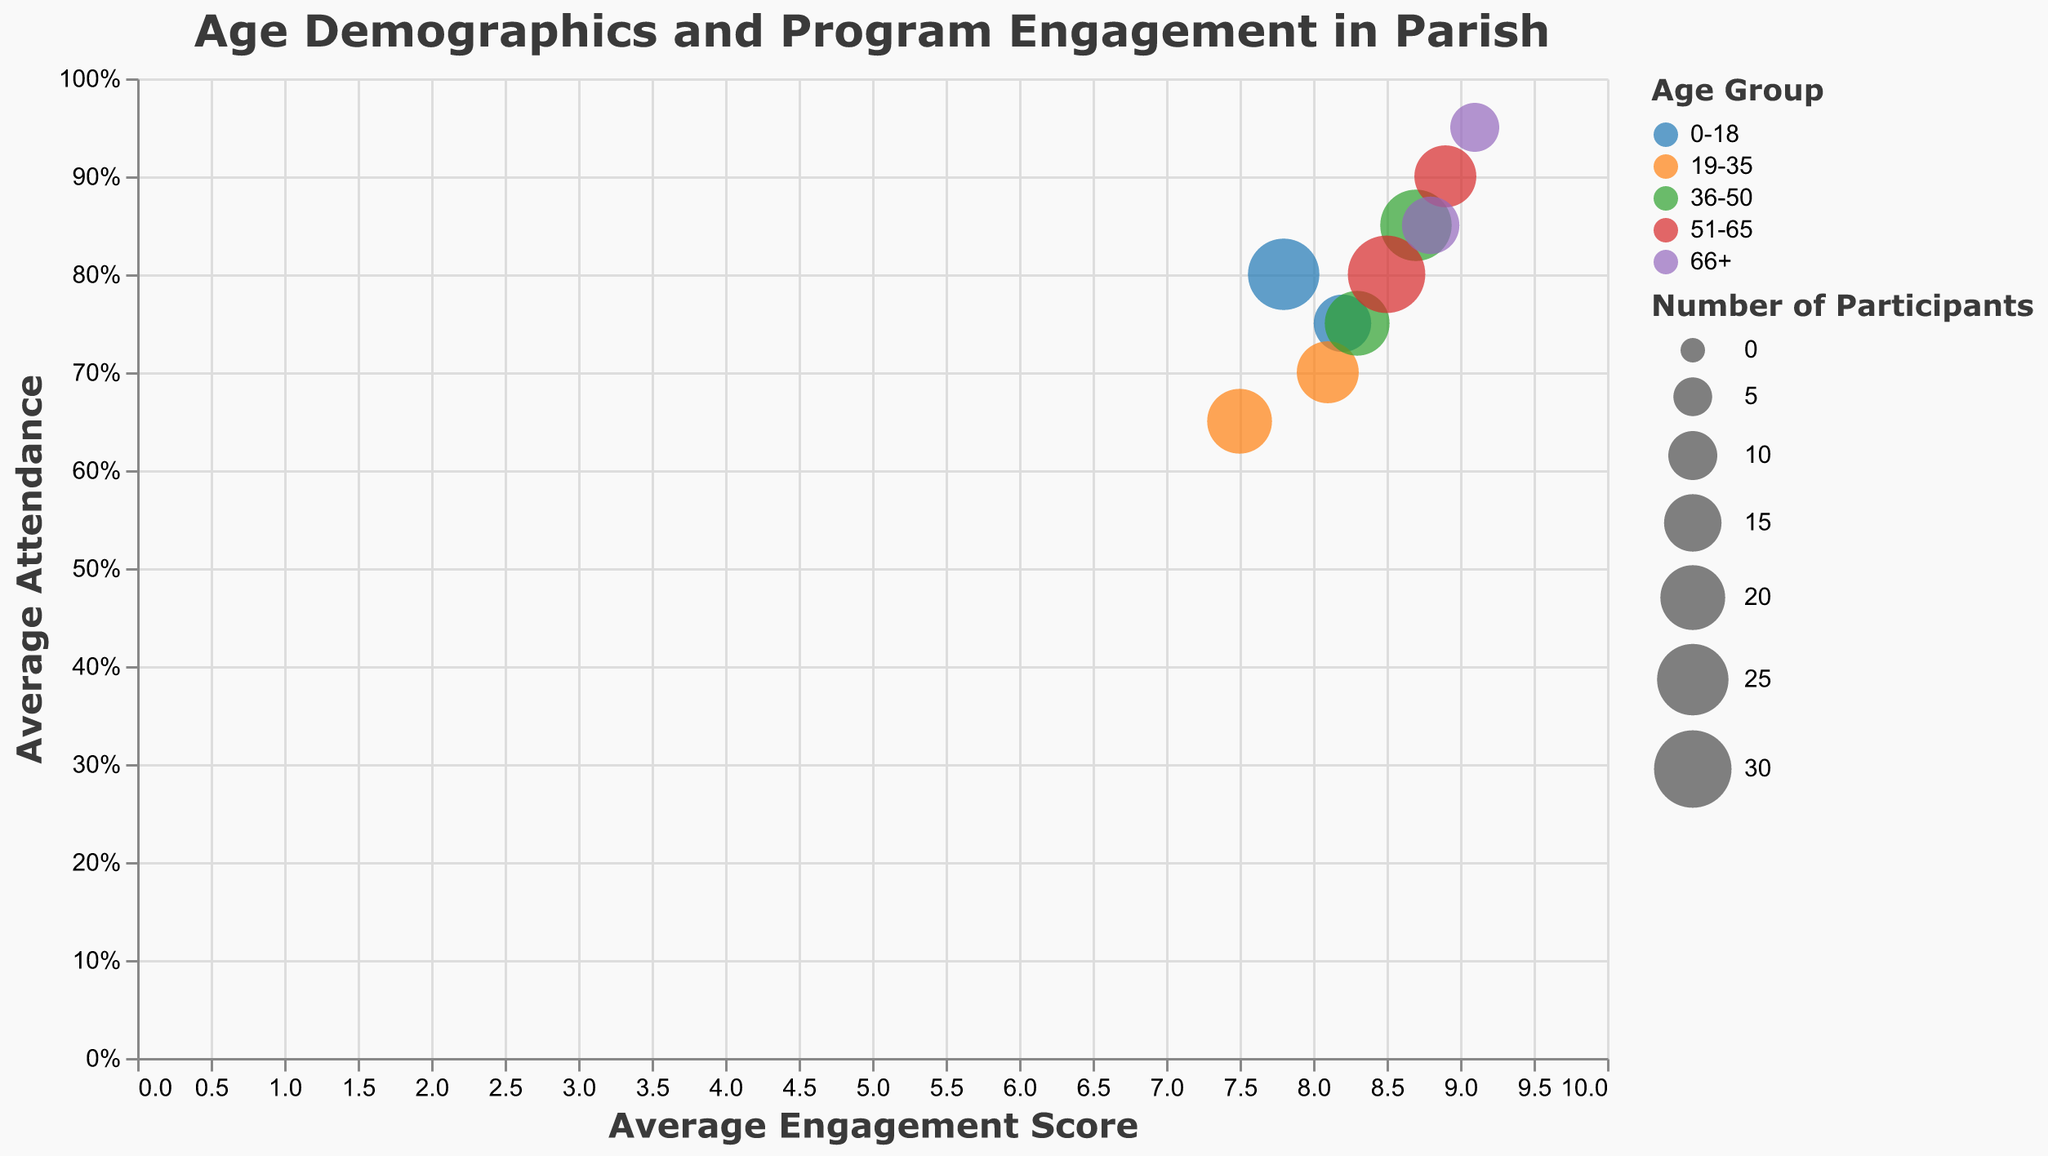What's the title of the chart? The title is usually displayed at the top of the chart. Here, it reads "Age Demographics and Program Engagement in Parish".
Answer: Age Demographics and Program Engagement in Parish Which age group shows the highest engagement score? We need to identify the bubble with the highest value on the x-axis. The highest engagement score is 9.1 for the 66+ age group in the Community Service program.
Answer: 66+ Which program has the most participants? By looking at the size of the bubbles, the largest bubble represents the Bible Study Group in the 51-65 age group, which has 30 participants.
Answer: Bible Study Group in the 51-65 age group Compare the engagement scores of the Sunday School and Youth Group for the 0-18 age group. Which one is higher? We need to compare their positions on the x-axis. The Youth Group has an engagement score of 8.2, and the Sunday School has 7.8. Therefore, the Youth Group score is higher.
Answer: Youth Group Which program has the highest average attendance? Locate the bubble with the highest value on the y-axis. The highest attendance is 95% in the Community Service program for the 66+ age group.
Answer: Community Service in the 66+ age group How many programs have an average engagement score above 8.0? We need to count the bubbles with x-axis values greater than 8. There are 7 such programs: Youth Group, Bible Study Group (in 19-35, 36-50, and 51-65 age groups), Choir, Community Service (in the 51-65 and 66+ age groups), and Prayer Group.
Answer: 7 What is the average attendance of the Bible Study Group for the 36-50 age group? Locate the bubble for the Bible Study Group in the 36-50 age group on the y-axis. The average attendance is 85%.
Answer: 85% Which group has higher engagement, the 19-35 age group in Bible Study Group or the 36-50 age group in Choir? Compare the engagement score values on the x-axis for these two data points. The 19-35 age group in Bible Study Group has an engagement score of 8.1, while the 36-50 age group in Choir has 8.3. The Choir for the 36-50 age group has a slightly higher score.
Answer: 36-50 in Choir What's the difference in average attendance between the Young Adult Fellowship in the 19-35 age group and the Choir in the 36-50 age group? Subtract the attendance values: 75% (Choir in 36-50) - 65% (Young Adult Fellowship in 19-35) = 10%.
Answer: 10% 